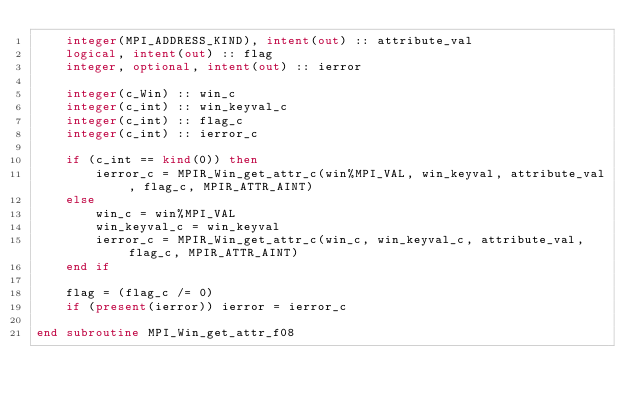Convert code to text. <code><loc_0><loc_0><loc_500><loc_500><_FORTRAN_>    integer(MPI_ADDRESS_KIND), intent(out) :: attribute_val
    logical, intent(out) :: flag
    integer, optional, intent(out) :: ierror

    integer(c_Win) :: win_c
    integer(c_int) :: win_keyval_c
    integer(c_int) :: flag_c
    integer(c_int) :: ierror_c

    if (c_int == kind(0)) then
        ierror_c = MPIR_Win_get_attr_c(win%MPI_VAL, win_keyval, attribute_val, flag_c, MPIR_ATTR_AINT)
    else
        win_c = win%MPI_VAL
        win_keyval_c = win_keyval
        ierror_c = MPIR_Win_get_attr_c(win_c, win_keyval_c, attribute_val, flag_c, MPIR_ATTR_AINT)
    end if

    flag = (flag_c /= 0)
    if (present(ierror)) ierror = ierror_c

end subroutine MPI_Win_get_attr_f08
</code> 